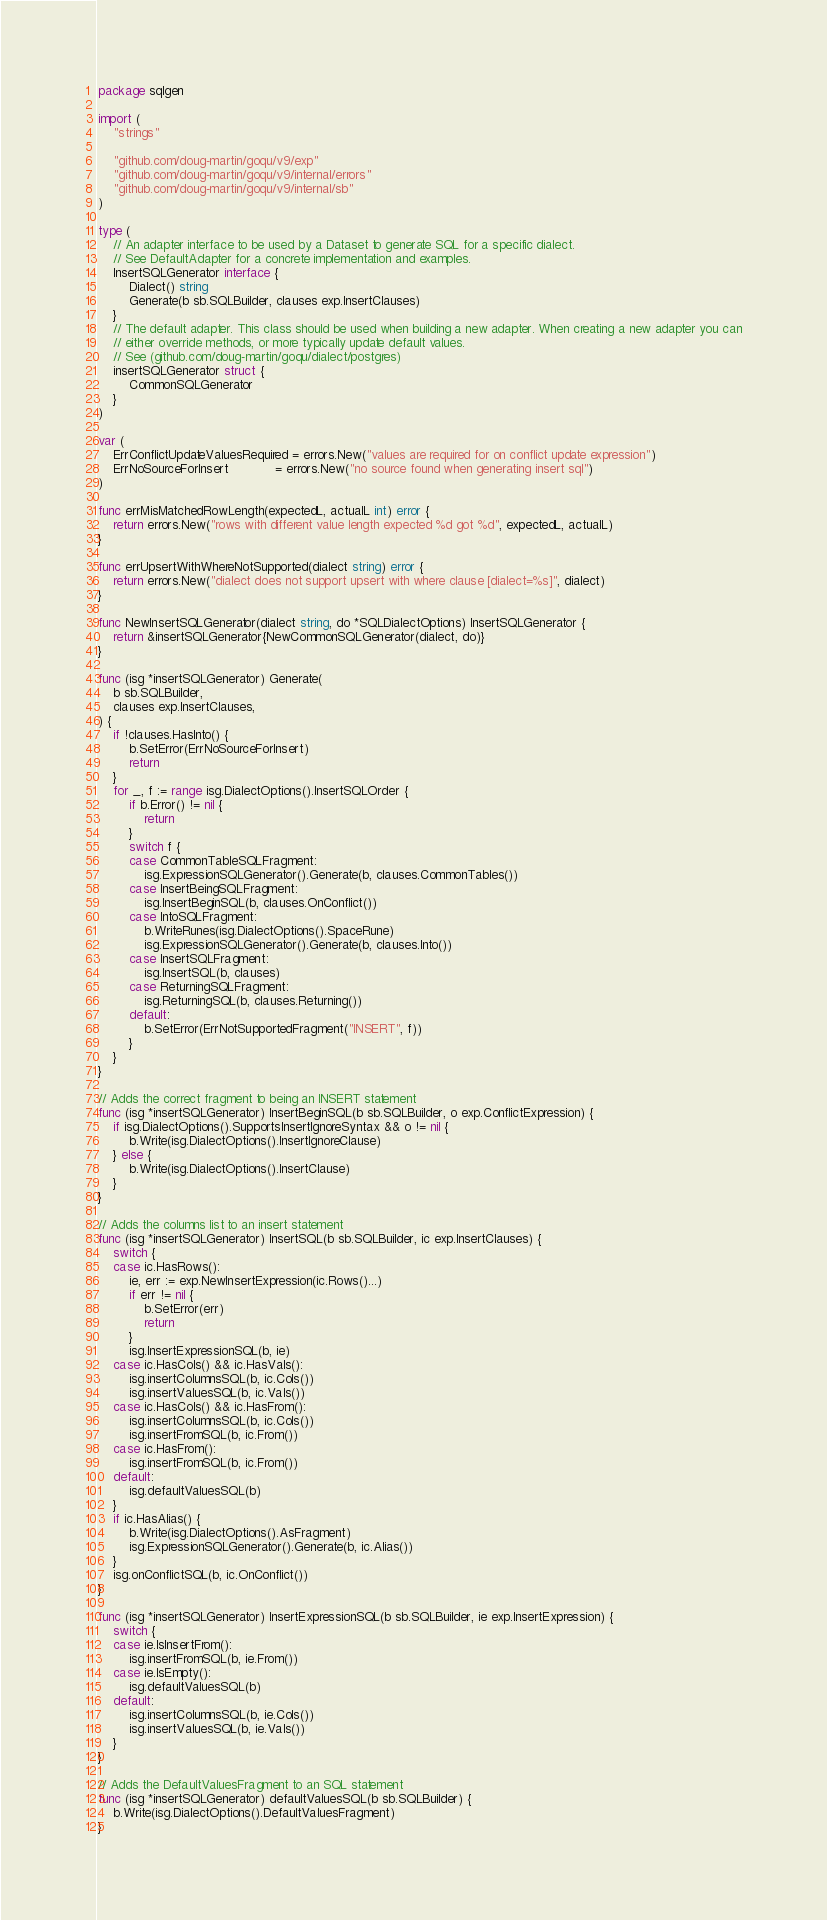<code> <loc_0><loc_0><loc_500><loc_500><_Go_>package sqlgen

import (
	"strings"

	"github.com/doug-martin/goqu/v9/exp"
	"github.com/doug-martin/goqu/v9/internal/errors"
	"github.com/doug-martin/goqu/v9/internal/sb"
)

type (
	// An adapter interface to be used by a Dataset to generate SQL for a specific dialect.
	// See DefaultAdapter for a concrete implementation and examples.
	InsertSQLGenerator interface {
		Dialect() string
		Generate(b sb.SQLBuilder, clauses exp.InsertClauses)
	}
	// The default adapter. This class should be used when building a new adapter. When creating a new adapter you can
	// either override methods, or more typically update default values.
	// See (github.com/doug-martin/goqu/dialect/postgres)
	insertSQLGenerator struct {
		CommonSQLGenerator
	}
)

var (
	ErrConflictUpdateValuesRequired = errors.New("values are required for on conflict update expression")
	ErrNoSourceForInsert            = errors.New("no source found when generating insert sql")
)

func errMisMatchedRowLength(expectedL, actualL int) error {
	return errors.New("rows with different value length expected %d got %d", expectedL, actualL)
}

func errUpsertWithWhereNotSupported(dialect string) error {
	return errors.New("dialect does not support upsert with where clause [dialect=%s]", dialect)
}

func NewInsertSQLGenerator(dialect string, do *SQLDialectOptions) InsertSQLGenerator {
	return &insertSQLGenerator{NewCommonSQLGenerator(dialect, do)}
}

func (isg *insertSQLGenerator) Generate(
	b sb.SQLBuilder,
	clauses exp.InsertClauses,
) {
	if !clauses.HasInto() {
		b.SetError(ErrNoSourceForInsert)
		return
	}
	for _, f := range isg.DialectOptions().InsertSQLOrder {
		if b.Error() != nil {
			return
		}
		switch f {
		case CommonTableSQLFragment:
			isg.ExpressionSQLGenerator().Generate(b, clauses.CommonTables())
		case InsertBeingSQLFragment:
			isg.InsertBeginSQL(b, clauses.OnConflict())
		case IntoSQLFragment:
			b.WriteRunes(isg.DialectOptions().SpaceRune)
			isg.ExpressionSQLGenerator().Generate(b, clauses.Into())
		case InsertSQLFragment:
			isg.InsertSQL(b, clauses)
		case ReturningSQLFragment:
			isg.ReturningSQL(b, clauses.Returning())
		default:
			b.SetError(ErrNotSupportedFragment("INSERT", f))
		}
	}
}

// Adds the correct fragment to being an INSERT statement
func (isg *insertSQLGenerator) InsertBeginSQL(b sb.SQLBuilder, o exp.ConflictExpression) {
	if isg.DialectOptions().SupportsInsertIgnoreSyntax && o != nil {
		b.Write(isg.DialectOptions().InsertIgnoreClause)
	} else {
		b.Write(isg.DialectOptions().InsertClause)
	}
}

// Adds the columns list to an insert statement
func (isg *insertSQLGenerator) InsertSQL(b sb.SQLBuilder, ic exp.InsertClauses) {
	switch {
	case ic.HasRows():
		ie, err := exp.NewInsertExpression(ic.Rows()...)
		if err != nil {
			b.SetError(err)
			return
		}
		isg.InsertExpressionSQL(b, ie)
	case ic.HasCols() && ic.HasVals():
		isg.insertColumnsSQL(b, ic.Cols())
		isg.insertValuesSQL(b, ic.Vals())
	case ic.HasCols() && ic.HasFrom():
		isg.insertColumnsSQL(b, ic.Cols())
		isg.insertFromSQL(b, ic.From())
	case ic.HasFrom():
		isg.insertFromSQL(b, ic.From())
	default:
		isg.defaultValuesSQL(b)
	}
	if ic.HasAlias() {
		b.Write(isg.DialectOptions().AsFragment)
		isg.ExpressionSQLGenerator().Generate(b, ic.Alias())
	}
	isg.onConflictSQL(b, ic.OnConflict())
}

func (isg *insertSQLGenerator) InsertExpressionSQL(b sb.SQLBuilder, ie exp.InsertExpression) {
	switch {
	case ie.IsInsertFrom():
		isg.insertFromSQL(b, ie.From())
	case ie.IsEmpty():
		isg.defaultValuesSQL(b)
	default:
		isg.insertColumnsSQL(b, ie.Cols())
		isg.insertValuesSQL(b, ie.Vals())
	}
}

// Adds the DefaultValuesFragment to an SQL statement
func (isg *insertSQLGenerator) defaultValuesSQL(b sb.SQLBuilder) {
	b.Write(isg.DialectOptions().DefaultValuesFragment)
}
</code> 